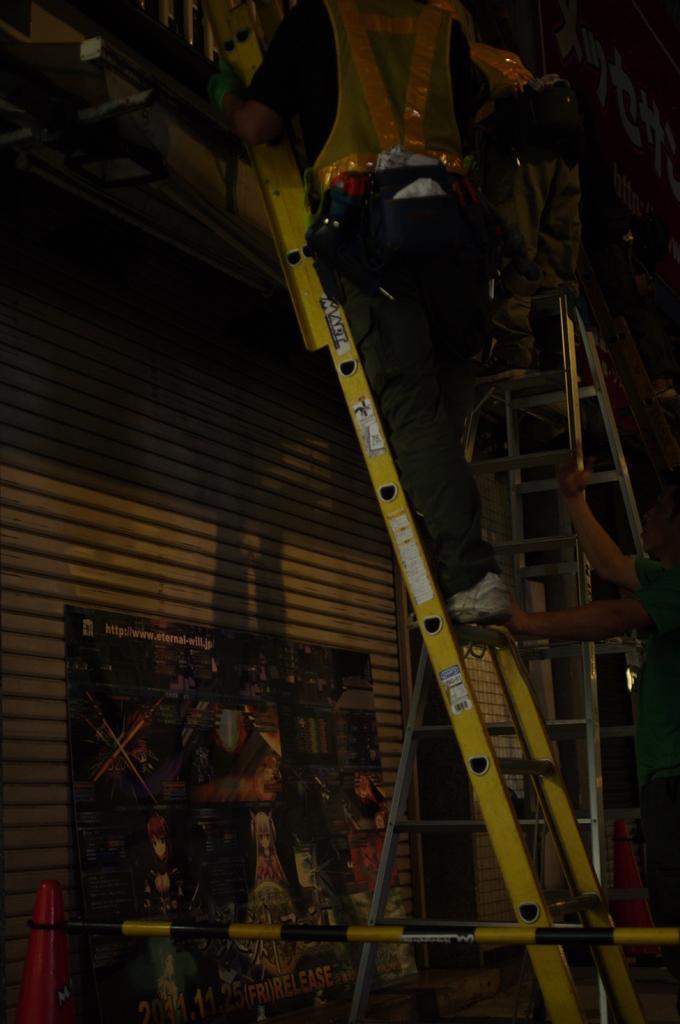Describe this image in one or two sentences. In this image we can see a man climbing a ladder and the other one holding a ladder. Below the ladder we can see an advertisement, traffic cone and an iron pole. 